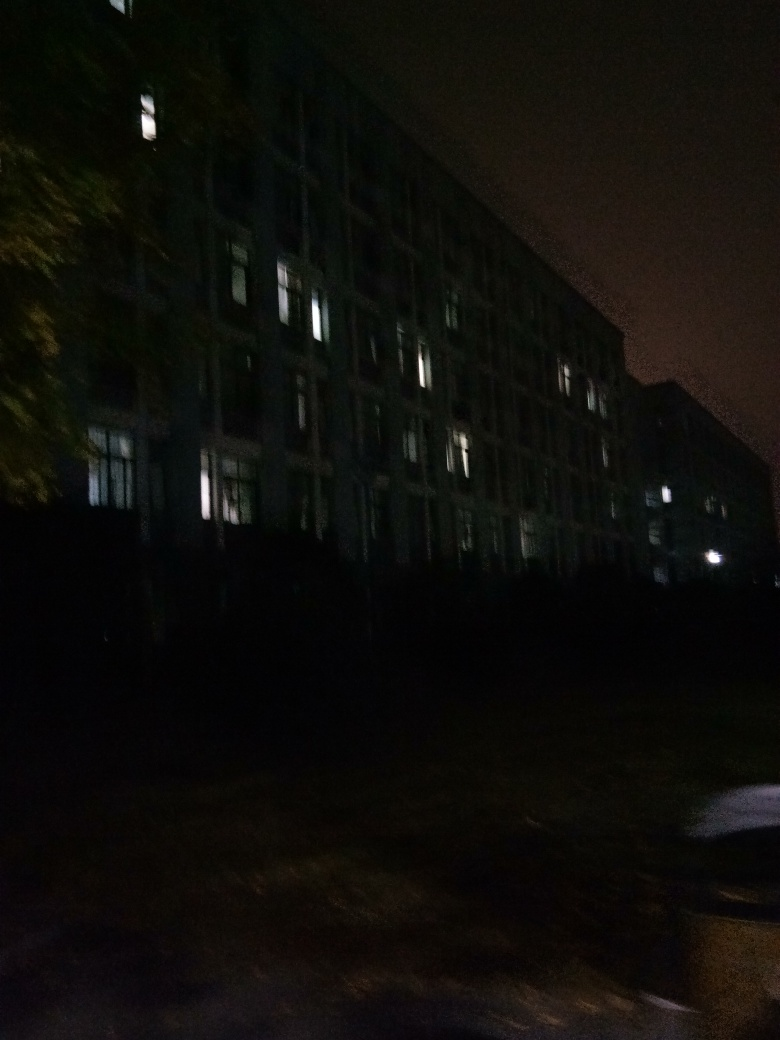Can you describe the architectural style of the building shown? The building in the photo features a repetitive pattern of windows and what seems to be a flat facade, which may suggest a modern or contemporary architectural style, typical for urban office buildings or apartments. The style emphasizes functionality and may lack ornamental detailing common in earlier architectural styles. Could there be any historical significance to this building? Without specific details on the location or history of the building, it's difficult to ascertain its historical significance. However, the uniform structure suggests it could be part of a larger planned development or a representative example of its era's architectural trends. 